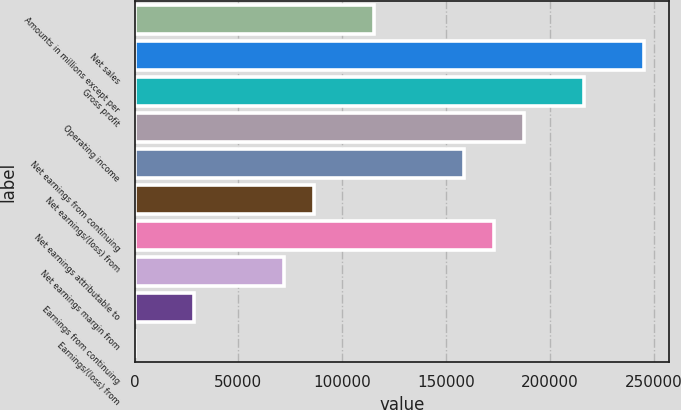Convert chart to OTSL. <chart><loc_0><loc_0><loc_500><loc_500><bar_chart><fcel>Amounts in millions except per<fcel>Net sales<fcel>Gross profit<fcel>Operating income<fcel>Net earnings from continuing<fcel>Net earnings/(loss) from<fcel>Net earnings attributable to<fcel>Net earnings margin from<fcel>Earnings from continuing<fcel>Earnings/(loss) from<nl><fcel>115413<fcel>245252<fcel>216399<fcel>187546<fcel>158693<fcel>86559.8<fcel>173119<fcel>72133.2<fcel>28853.5<fcel>0.41<nl></chart> 